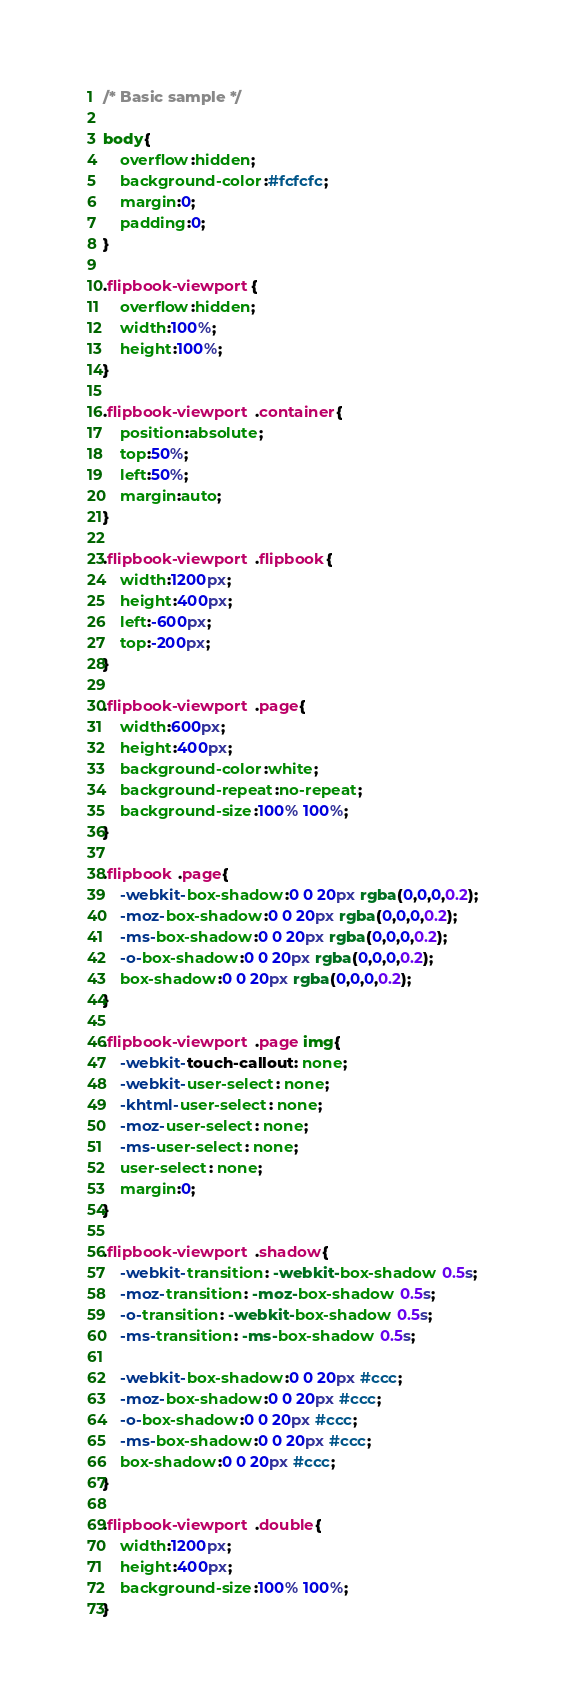<code> <loc_0><loc_0><loc_500><loc_500><_CSS_>/* Basic sample */

body{
	overflow:hidden;
	background-color:#fcfcfc;
	margin:0;
	padding:0;
}

.flipbook-viewport{
	overflow:hidden;
	width:100%;
	height:100%;
}

.flipbook-viewport .container{
	position:absolute;
	top:50%;
	left:50%;
	margin:auto;
}

.flipbook-viewport .flipbook{
	width:1200px;
	height:400px;
	left:-600px;
	top:-200px;
}

.flipbook-viewport .page{
	width:600px;
	height:400px;
	background-color:white;
	background-repeat:no-repeat;
	background-size:100% 100%;
}

.flipbook .page{
	-webkit-box-shadow:0 0 20px rgba(0,0,0,0.2);
	-moz-box-shadow:0 0 20px rgba(0,0,0,0.2);
	-ms-box-shadow:0 0 20px rgba(0,0,0,0.2);
	-o-box-shadow:0 0 20px rgba(0,0,0,0.2);
	box-shadow:0 0 20px rgba(0,0,0,0.2);
}

.flipbook-viewport .page img{
	-webkit-touch-callout: none;
	-webkit-user-select: none;
	-khtml-user-select: none;
	-moz-user-select: none;
	-ms-user-select: none;
	user-select: none;
	margin:0;
}

.flipbook-viewport .shadow{
	-webkit-transition: -webkit-box-shadow 0.5s;
	-moz-transition: -moz-box-shadow 0.5s;
	-o-transition: -webkit-box-shadow 0.5s;
	-ms-transition: -ms-box-shadow 0.5s;

	-webkit-box-shadow:0 0 20px #ccc;
	-moz-box-shadow:0 0 20px #ccc;
	-o-box-shadow:0 0 20px #ccc;
	-ms-box-shadow:0 0 20px #ccc;
	box-shadow:0 0 20px #ccc;
}

.flipbook-viewport .double{
	width:1200px;
	height:400px;
	background-size:100% 100%;
}
</code> 